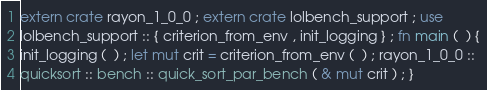<code> <loc_0><loc_0><loc_500><loc_500><_Rust_>extern crate rayon_1_0_0 ; extern crate lolbench_support ; use
lolbench_support :: { criterion_from_env , init_logging } ; fn main (  ) {
init_logging (  ) ; let mut crit = criterion_from_env (  ) ; rayon_1_0_0 ::
quicksort :: bench :: quick_sort_par_bench ( & mut crit ) ; }</code> 